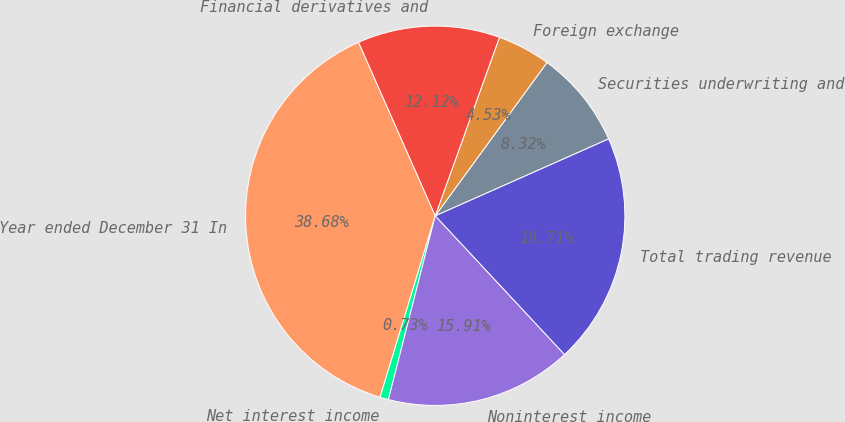Convert chart. <chart><loc_0><loc_0><loc_500><loc_500><pie_chart><fcel>Year ended December 31 In<fcel>Net interest income<fcel>Noninterest income<fcel>Total trading revenue<fcel>Securities underwriting and<fcel>Foreign exchange<fcel>Financial derivatives and<nl><fcel>38.68%<fcel>0.73%<fcel>15.91%<fcel>19.71%<fcel>8.32%<fcel>4.53%<fcel>12.12%<nl></chart> 